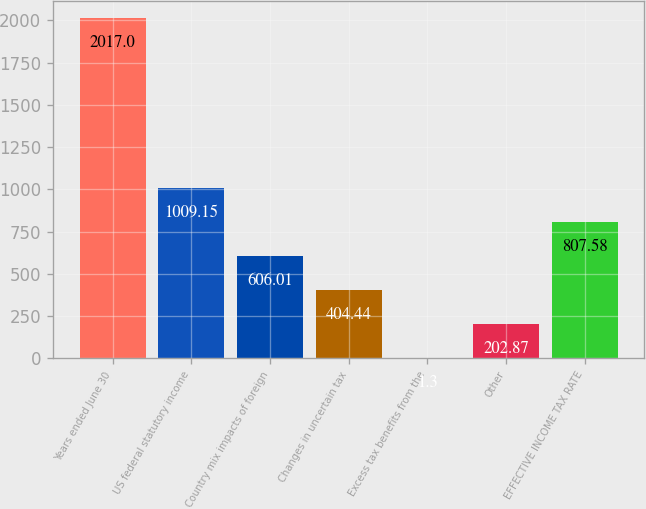<chart> <loc_0><loc_0><loc_500><loc_500><bar_chart><fcel>Years ended June 30<fcel>US federal statutory income<fcel>Country mix impacts of foreign<fcel>Changes in uncertain tax<fcel>Excess tax benefits from the<fcel>Other<fcel>EFFECTIVE INCOME TAX RATE<nl><fcel>2017<fcel>1009.15<fcel>606.01<fcel>404.44<fcel>1.3<fcel>202.87<fcel>807.58<nl></chart> 